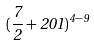<formula> <loc_0><loc_0><loc_500><loc_500>( \frac { 7 } { 2 } + 2 0 1 ) ^ { 4 - 9 }</formula> 